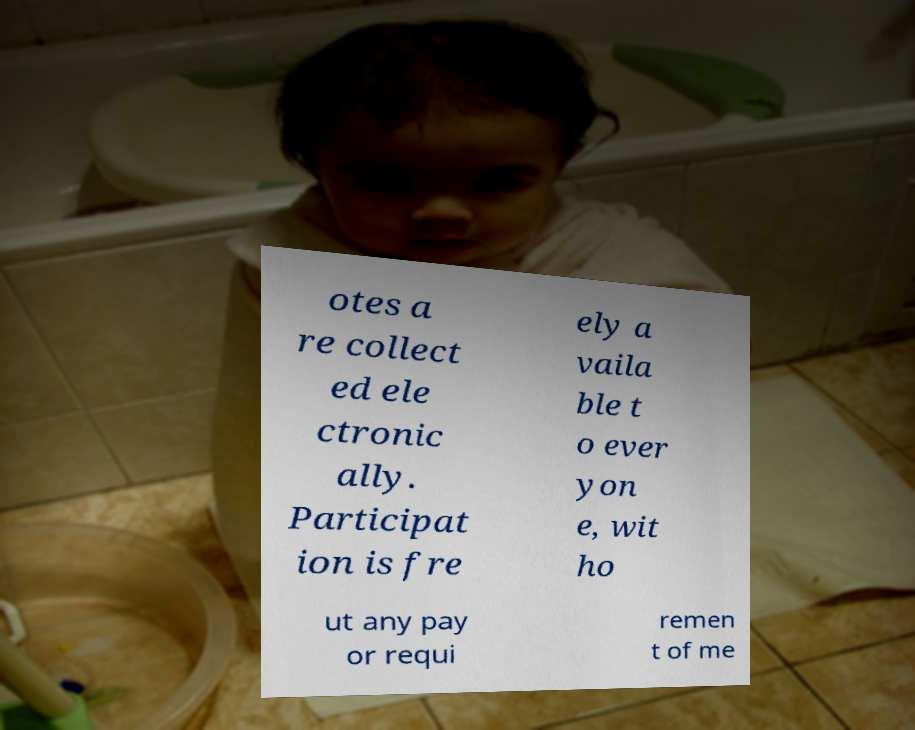For documentation purposes, I need the text within this image transcribed. Could you provide that? otes a re collect ed ele ctronic ally. Participat ion is fre ely a vaila ble t o ever yon e, wit ho ut any pay or requi remen t of me 